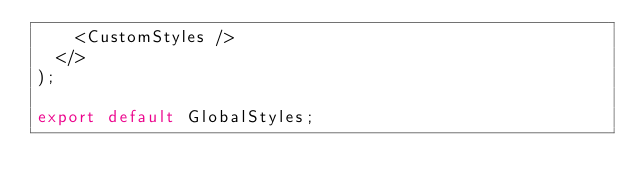<code> <loc_0><loc_0><loc_500><loc_500><_TypeScript_>    <CustomStyles />
  </>
);

export default GlobalStyles;
</code> 